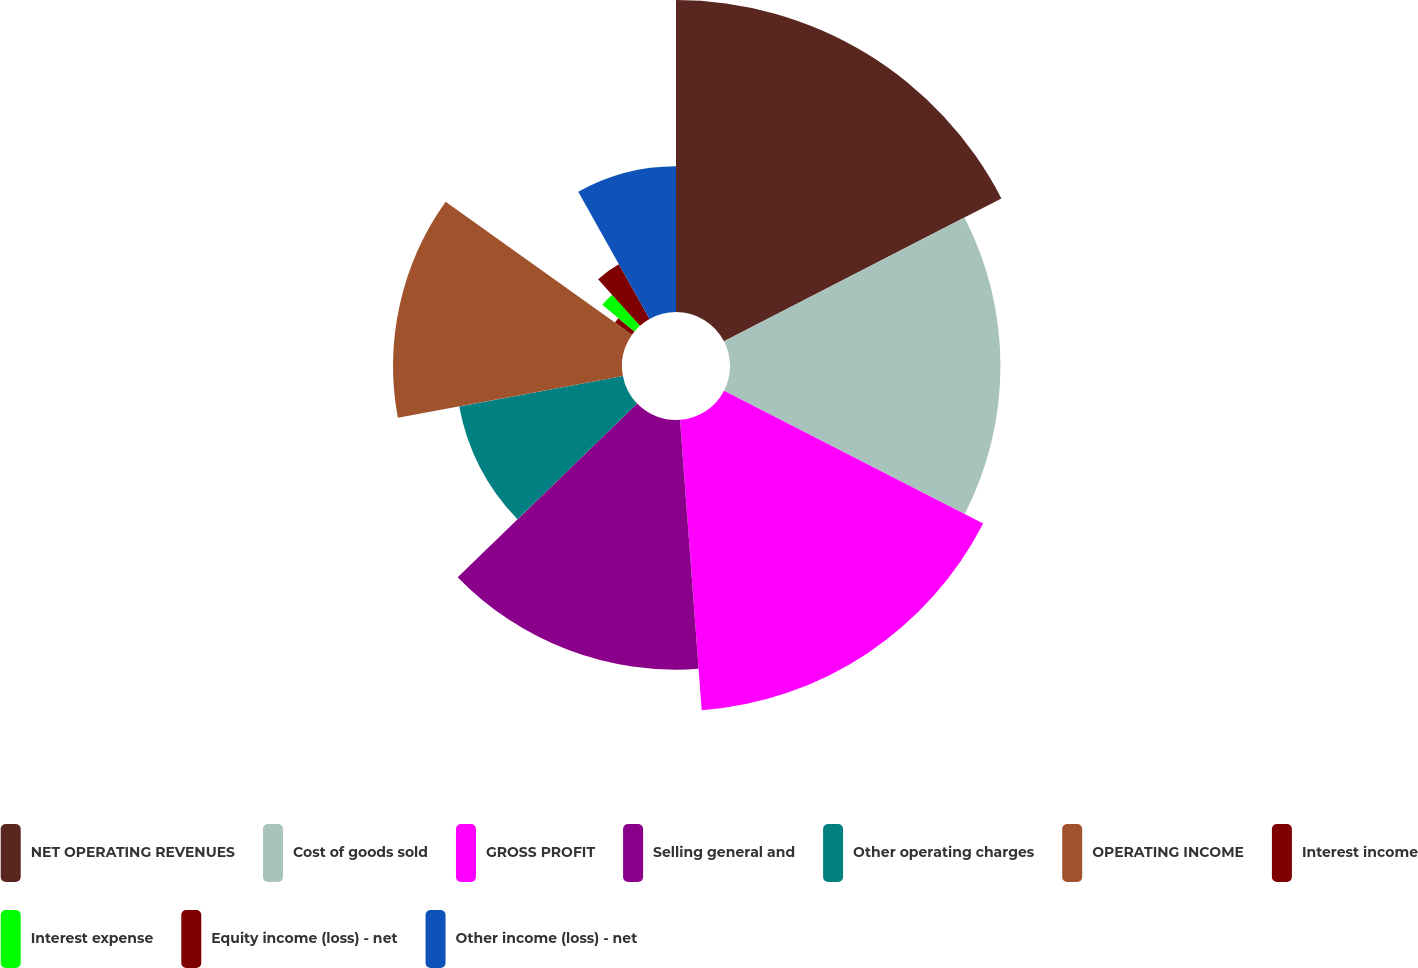<chart> <loc_0><loc_0><loc_500><loc_500><pie_chart><fcel>NET OPERATING REVENUES<fcel>Cost of goods sold<fcel>GROSS PROFIT<fcel>Selling general and<fcel>Other operating charges<fcel>OPERATING INCOME<fcel>Interest income<fcel>Interest expense<fcel>Equity income (loss) - net<fcel>Other income (loss) - net<nl><fcel>17.43%<fcel>15.11%<fcel>16.27%<fcel>13.95%<fcel>9.3%<fcel>12.79%<fcel>1.17%<fcel>2.33%<fcel>3.5%<fcel>8.14%<nl></chart> 